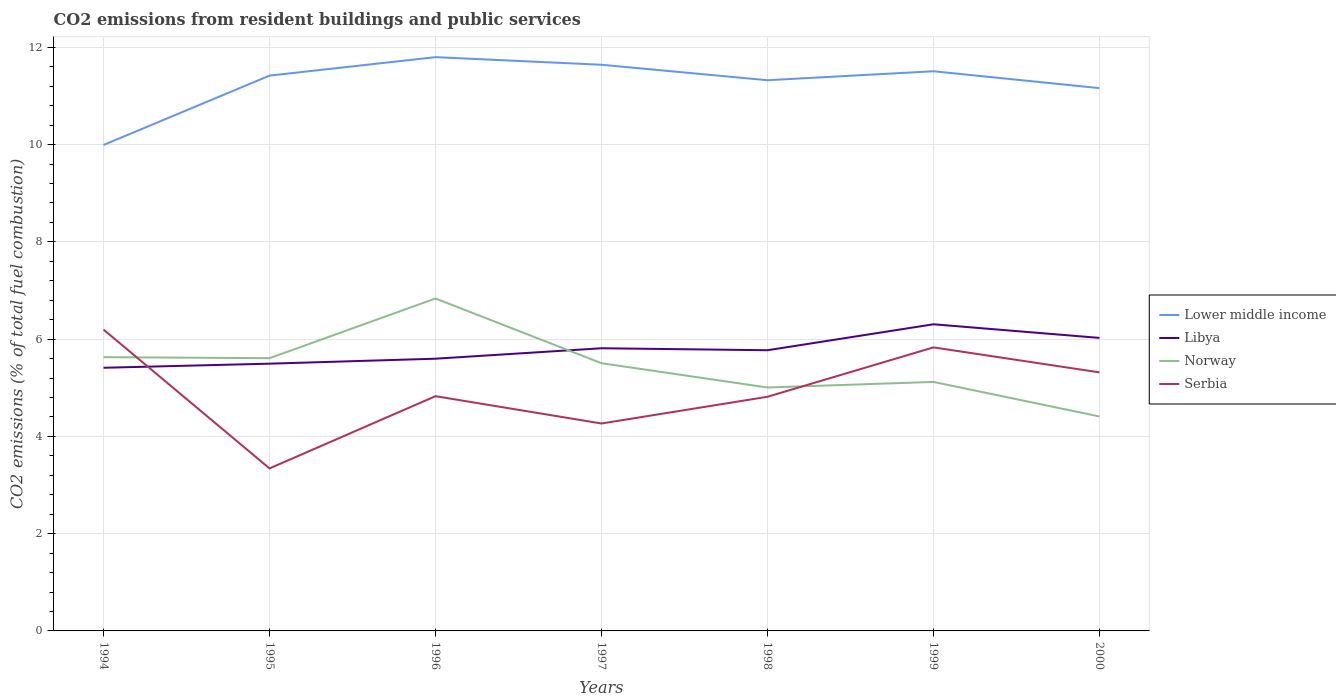How many different coloured lines are there?
Keep it short and to the point. 4. Does the line corresponding to Lower middle income intersect with the line corresponding to Norway?
Offer a very short reply. No. Across all years, what is the maximum total CO2 emitted in Norway?
Give a very brief answer. 4.41. What is the total total CO2 emitted in Norway in the graph?
Your answer should be very brief. 0.5. What is the difference between the highest and the second highest total CO2 emitted in Lower middle income?
Your response must be concise. 1.81. What is the difference between the highest and the lowest total CO2 emitted in Serbia?
Provide a short and direct response. 3. How many lines are there?
Your answer should be very brief. 4. How many years are there in the graph?
Offer a very short reply. 7. What is the difference between two consecutive major ticks on the Y-axis?
Ensure brevity in your answer.  2. Are the values on the major ticks of Y-axis written in scientific E-notation?
Provide a short and direct response. No. Does the graph contain grids?
Your answer should be compact. Yes. How are the legend labels stacked?
Your answer should be very brief. Vertical. What is the title of the graph?
Offer a very short reply. CO2 emissions from resident buildings and public services. What is the label or title of the X-axis?
Offer a very short reply. Years. What is the label or title of the Y-axis?
Make the answer very short. CO2 emissions (% of total fuel combustion). What is the CO2 emissions (% of total fuel combustion) of Lower middle income in 1994?
Provide a short and direct response. 9.99. What is the CO2 emissions (% of total fuel combustion) of Libya in 1994?
Offer a terse response. 5.41. What is the CO2 emissions (% of total fuel combustion) in Norway in 1994?
Give a very brief answer. 5.63. What is the CO2 emissions (% of total fuel combustion) in Serbia in 1994?
Keep it short and to the point. 6.2. What is the CO2 emissions (% of total fuel combustion) in Lower middle income in 1995?
Make the answer very short. 11.42. What is the CO2 emissions (% of total fuel combustion) of Libya in 1995?
Your answer should be very brief. 5.5. What is the CO2 emissions (% of total fuel combustion) of Norway in 1995?
Your response must be concise. 5.61. What is the CO2 emissions (% of total fuel combustion) of Serbia in 1995?
Your answer should be very brief. 3.34. What is the CO2 emissions (% of total fuel combustion) in Lower middle income in 1996?
Provide a short and direct response. 11.8. What is the CO2 emissions (% of total fuel combustion) of Libya in 1996?
Keep it short and to the point. 5.6. What is the CO2 emissions (% of total fuel combustion) in Norway in 1996?
Your answer should be very brief. 6.84. What is the CO2 emissions (% of total fuel combustion) of Serbia in 1996?
Offer a terse response. 4.83. What is the CO2 emissions (% of total fuel combustion) in Lower middle income in 1997?
Give a very brief answer. 11.64. What is the CO2 emissions (% of total fuel combustion) of Libya in 1997?
Offer a terse response. 5.81. What is the CO2 emissions (% of total fuel combustion) of Norway in 1997?
Your answer should be very brief. 5.51. What is the CO2 emissions (% of total fuel combustion) of Serbia in 1997?
Provide a short and direct response. 4.27. What is the CO2 emissions (% of total fuel combustion) of Lower middle income in 1998?
Offer a terse response. 11.32. What is the CO2 emissions (% of total fuel combustion) in Libya in 1998?
Your answer should be compact. 5.77. What is the CO2 emissions (% of total fuel combustion) of Norway in 1998?
Offer a very short reply. 5.01. What is the CO2 emissions (% of total fuel combustion) of Serbia in 1998?
Keep it short and to the point. 4.81. What is the CO2 emissions (% of total fuel combustion) of Lower middle income in 1999?
Make the answer very short. 11.51. What is the CO2 emissions (% of total fuel combustion) in Libya in 1999?
Ensure brevity in your answer.  6.31. What is the CO2 emissions (% of total fuel combustion) in Norway in 1999?
Give a very brief answer. 5.12. What is the CO2 emissions (% of total fuel combustion) of Serbia in 1999?
Make the answer very short. 5.83. What is the CO2 emissions (% of total fuel combustion) of Lower middle income in 2000?
Make the answer very short. 11.16. What is the CO2 emissions (% of total fuel combustion) in Libya in 2000?
Make the answer very short. 6.03. What is the CO2 emissions (% of total fuel combustion) of Norway in 2000?
Make the answer very short. 4.41. What is the CO2 emissions (% of total fuel combustion) of Serbia in 2000?
Provide a succinct answer. 5.32. Across all years, what is the maximum CO2 emissions (% of total fuel combustion) of Lower middle income?
Give a very brief answer. 11.8. Across all years, what is the maximum CO2 emissions (% of total fuel combustion) in Libya?
Provide a succinct answer. 6.31. Across all years, what is the maximum CO2 emissions (% of total fuel combustion) of Norway?
Your answer should be compact. 6.84. Across all years, what is the maximum CO2 emissions (% of total fuel combustion) of Serbia?
Keep it short and to the point. 6.2. Across all years, what is the minimum CO2 emissions (% of total fuel combustion) in Lower middle income?
Provide a succinct answer. 9.99. Across all years, what is the minimum CO2 emissions (% of total fuel combustion) of Libya?
Offer a very short reply. 5.41. Across all years, what is the minimum CO2 emissions (% of total fuel combustion) of Norway?
Provide a succinct answer. 4.41. Across all years, what is the minimum CO2 emissions (% of total fuel combustion) in Serbia?
Your answer should be compact. 3.34. What is the total CO2 emissions (% of total fuel combustion) of Lower middle income in the graph?
Ensure brevity in your answer.  78.84. What is the total CO2 emissions (% of total fuel combustion) in Libya in the graph?
Provide a succinct answer. 40.42. What is the total CO2 emissions (% of total fuel combustion) of Norway in the graph?
Your answer should be compact. 38.11. What is the total CO2 emissions (% of total fuel combustion) of Serbia in the graph?
Provide a succinct answer. 34.59. What is the difference between the CO2 emissions (% of total fuel combustion) of Lower middle income in 1994 and that in 1995?
Give a very brief answer. -1.43. What is the difference between the CO2 emissions (% of total fuel combustion) in Libya in 1994 and that in 1995?
Your answer should be compact. -0.08. What is the difference between the CO2 emissions (% of total fuel combustion) of Norway in 1994 and that in 1995?
Keep it short and to the point. 0.02. What is the difference between the CO2 emissions (% of total fuel combustion) of Serbia in 1994 and that in 1995?
Give a very brief answer. 2.85. What is the difference between the CO2 emissions (% of total fuel combustion) of Lower middle income in 1994 and that in 1996?
Your response must be concise. -1.81. What is the difference between the CO2 emissions (% of total fuel combustion) in Libya in 1994 and that in 1996?
Keep it short and to the point. -0.19. What is the difference between the CO2 emissions (% of total fuel combustion) of Norway in 1994 and that in 1996?
Your response must be concise. -1.21. What is the difference between the CO2 emissions (% of total fuel combustion) in Serbia in 1994 and that in 1996?
Keep it short and to the point. 1.37. What is the difference between the CO2 emissions (% of total fuel combustion) of Lower middle income in 1994 and that in 1997?
Your response must be concise. -1.65. What is the difference between the CO2 emissions (% of total fuel combustion) of Libya in 1994 and that in 1997?
Your answer should be very brief. -0.4. What is the difference between the CO2 emissions (% of total fuel combustion) in Norway in 1994 and that in 1997?
Offer a terse response. 0.12. What is the difference between the CO2 emissions (% of total fuel combustion) of Serbia in 1994 and that in 1997?
Your response must be concise. 1.93. What is the difference between the CO2 emissions (% of total fuel combustion) of Lower middle income in 1994 and that in 1998?
Your answer should be compact. -1.33. What is the difference between the CO2 emissions (% of total fuel combustion) in Libya in 1994 and that in 1998?
Provide a short and direct response. -0.36. What is the difference between the CO2 emissions (% of total fuel combustion) in Norway in 1994 and that in 1998?
Offer a terse response. 0.62. What is the difference between the CO2 emissions (% of total fuel combustion) in Serbia in 1994 and that in 1998?
Offer a terse response. 1.38. What is the difference between the CO2 emissions (% of total fuel combustion) in Lower middle income in 1994 and that in 1999?
Keep it short and to the point. -1.52. What is the difference between the CO2 emissions (% of total fuel combustion) in Libya in 1994 and that in 1999?
Keep it short and to the point. -0.89. What is the difference between the CO2 emissions (% of total fuel combustion) in Norway in 1994 and that in 1999?
Make the answer very short. 0.51. What is the difference between the CO2 emissions (% of total fuel combustion) of Serbia in 1994 and that in 1999?
Your answer should be compact. 0.37. What is the difference between the CO2 emissions (% of total fuel combustion) of Lower middle income in 1994 and that in 2000?
Your response must be concise. -1.17. What is the difference between the CO2 emissions (% of total fuel combustion) in Libya in 1994 and that in 2000?
Your response must be concise. -0.61. What is the difference between the CO2 emissions (% of total fuel combustion) in Norway in 1994 and that in 2000?
Your response must be concise. 1.22. What is the difference between the CO2 emissions (% of total fuel combustion) of Serbia in 1994 and that in 2000?
Make the answer very short. 0.88. What is the difference between the CO2 emissions (% of total fuel combustion) of Lower middle income in 1995 and that in 1996?
Your answer should be compact. -0.38. What is the difference between the CO2 emissions (% of total fuel combustion) in Libya in 1995 and that in 1996?
Offer a terse response. -0.1. What is the difference between the CO2 emissions (% of total fuel combustion) of Norway in 1995 and that in 1996?
Provide a short and direct response. -1.23. What is the difference between the CO2 emissions (% of total fuel combustion) in Serbia in 1995 and that in 1996?
Provide a succinct answer. -1.49. What is the difference between the CO2 emissions (% of total fuel combustion) in Lower middle income in 1995 and that in 1997?
Provide a succinct answer. -0.22. What is the difference between the CO2 emissions (% of total fuel combustion) of Libya in 1995 and that in 1997?
Your response must be concise. -0.32. What is the difference between the CO2 emissions (% of total fuel combustion) in Norway in 1995 and that in 1997?
Provide a succinct answer. 0.1. What is the difference between the CO2 emissions (% of total fuel combustion) in Serbia in 1995 and that in 1997?
Make the answer very short. -0.92. What is the difference between the CO2 emissions (% of total fuel combustion) in Lower middle income in 1995 and that in 1998?
Provide a short and direct response. 0.09. What is the difference between the CO2 emissions (% of total fuel combustion) of Libya in 1995 and that in 1998?
Give a very brief answer. -0.28. What is the difference between the CO2 emissions (% of total fuel combustion) of Norway in 1995 and that in 1998?
Keep it short and to the point. 0.6. What is the difference between the CO2 emissions (% of total fuel combustion) of Serbia in 1995 and that in 1998?
Your answer should be very brief. -1.47. What is the difference between the CO2 emissions (% of total fuel combustion) of Lower middle income in 1995 and that in 1999?
Make the answer very short. -0.09. What is the difference between the CO2 emissions (% of total fuel combustion) in Libya in 1995 and that in 1999?
Provide a succinct answer. -0.81. What is the difference between the CO2 emissions (% of total fuel combustion) of Norway in 1995 and that in 1999?
Your answer should be compact. 0.49. What is the difference between the CO2 emissions (% of total fuel combustion) in Serbia in 1995 and that in 1999?
Your answer should be very brief. -2.49. What is the difference between the CO2 emissions (% of total fuel combustion) in Lower middle income in 1995 and that in 2000?
Your answer should be very brief. 0.26. What is the difference between the CO2 emissions (% of total fuel combustion) of Libya in 1995 and that in 2000?
Your answer should be compact. -0.53. What is the difference between the CO2 emissions (% of total fuel combustion) of Norway in 1995 and that in 2000?
Your answer should be compact. 1.2. What is the difference between the CO2 emissions (% of total fuel combustion) of Serbia in 1995 and that in 2000?
Your answer should be compact. -1.97. What is the difference between the CO2 emissions (% of total fuel combustion) in Lower middle income in 1996 and that in 1997?
Provide a short and direct response. 0.16. What is the difference between the CO2 emissions (% of total fuel combustion) of Libya in 1996 and that in 1997?
Your answer should be compact. -0.21. What is the difference between the CO2 emissions (% of total fuel combustion) of Norway in 1996 and that in 1997?
Provide a succinct answer. 1.33. What is the difference between the CO2 emissions (% of total fuel combustion) of Serbia in 1996 and that in 1997?
Your answer should be very brief. 0.56. What is the difference between the CO2 emissions (% of total fuel combustion) in Lower middle income in 1996 and that in 1998?
Give a very brief answer. 0.47. What is the difference between the CO2 emissions (% of total fuel combustion) of Libya in 1996 and that in 1998?
Ensure brevity in your answer.  -0.17. What is the difference between the CO2 emissions (% of total fuel combustion) in Norway in 1996 and that in 1998?
Provide a short and direct response. 1.83. What is the difference between the CO2 emissions (% of total fuel combustion) in Serbia in 1996 and that in 1998?
Your response must be concise. 0.01. What is the difference between the CO2 emissions (% of total fuel combustion) in Lower middle income in 1996 and that in 1999?
Give a very brief answer. 0.29. What is the difference between the CO2 emissions (% of total fuel combustion) of Libya in 1996 and that in 1999?
Offer a very short reply. -0.71. What is the difference between the CO2 emissions (% of total fuel combustion) of Norway in 1996 and that in 1999?
Give a very brief answer. 1.72. What is the difference between the CO2 emissions (% of total fuel combustion) of Serbia in 1996 and that in 1999?
Make the answer very short. -1. What is the difference between the CO2 emissions (% of total fuel combustion) of Lower middle income in 1996 and that in 2000?
Ensure brevity in your answer.  0.64. What is the difference between the CO2 emissions (% of total fuel combustion) of Libya in 1996 and that in 2000?
Offer a very short reply. -0.43. What is the difference between the CO2 emissions (% of total fuel combustion) of Norway in 1996 and that in 2000?
Provide a short and direct response. 2.43. What is the difference between the CO2 emissions (% of total fuel combustion) in Serbia in 1996 and that in 2000?
Provide a succinct answer. -0.49. What is the difference between the CO2 emissions (% of total fuel combustion) of Lower middle income in 1997 and that in 1998?
Offer a very short reply. 0.32. What is the difference between the CO2 emissions (% of total fuel combustion) in Libya in 1997 and that in 1998?
Keep it short and to the point. 0.04. What is the difference between the CO2 emissions (% of total fuel combustion) of Norway in 1997 and that in 1998?
Provide a short and direct response. 0.5. What is the difference between the CO2 emissions (% of total fuel combustion) of Serbia in 1997 and that in 1998?
Your answer should be very brief. -0.55. What is the difference between the CO2 emissions (% of total fuel combustion) in Lower middle income in 1997 and that in 1999?
Keep it short and to the point. 0.13. What is the difference between the CO2 emissions (% of total fuel combustion) in Libya in 1997 and that in 1999?
Give a very brief answer. -0.49. What is the difference between the CO2 emissions (% of total fuel combustion) in Norway in 1997 and that in 1999?
Provide a succinct answer. 0.38. What is the difference between the CO2 emissions (% of total fuel combustion) of Serbia in 1997 and that in 1999?
Offer a terse response. -1.57. What is the difference between the CO2 emissions (% of total fuel combustion) in Lower middle income in 1997 and that in 2000?
Offer a very short reply. 0.48. What is the difference between the CO2 emissions (% of total fuel combustion) in Libya in 1997 and that in 2000?
Provide a succinct answer. -0.21. What is the difference between the CO2 emissions (% of total fuel combustion) of Norway in 1997 and that in 2000?
Provide a succinct answer. 1.1. What is the difference between the CO2 emissions (% of total fuel combustion) in Serbia in 1997 and that in 2000?
Keep it short and to the point. -1.05. What is the difference between the CO2 emissions (% of total fuel combustion) of Lower middle income in 1998 and that in 1999?
Your answer should be compact. -0.18. What is the difference between the CO2 emissions (% of total fuel combustion) of Libya in 1998 and that in 1999?
Provide a succinct answer. -0.53. What is the difference between the CO2 emissions (% of total fuel combustion) in Norway in 1998 and that in 1999?
Provide a short and direct response. -0.11. What is the difference between the CO2 emissions (% of total fuel combustion) in Serbia in 1998 and that in 1999?
Your answer should be compact. -1.02. What is the difference between the CO2 emissions (% of total fuel combustion) in Lower middle income in 1998 and that in 2000?
Your answer should be compact. 0.16. What is the difference between the CO2 emissions (% of total fuel combustion) of Libya in 1998 and that in 2000?
Your answer should be compact. -0.25. What is the difference between the CO2 emissions (% of total fuel combustion) of Norway in 1998 and that in 2000?
Offer a terse response. 0.6. What is the difference between the CO2 emissions (% of total fuel combustion) of Serbia in 1998 and that in 2000?
Offer a very short reply. -0.5. What is the difference between the CO2 emissions (% of total fuel combustion) in Lower middle income in 1999 and that in 2000?
Give a very brief answer. 0.35. What is the difference between the CO2 emissions (% of total fuel combustion) in Libya in 1999 and that in 2000?
Make the answer very short. 0.28. What is the difference between the CO2 emissions (% of total fuel combustion) of Norway in 1999 and that in 2000?
Keep it short and to the point. 0.71. What is the difference between the CO2 emissions (% of total fuel combustion) in Serbia in 1999 and that in 2000?
Your response must be concise. 0.51. What is the difference between the CO2 emissions (% of total fuel combustion) of Lower middle income in 1994 and the CO2 emissions (% of total fuel combustion) of Libya in 1995?
Give a very brief answer. 4.5. What is the difference between the CO2 emissions (% of total fuel combustion) in Lower middle income in 1994 and the CO2 emissions (% of total fuel combustion) in Norway in 1995?
Ensure brevity in your answer.  4.38. What is the difference between the CO2 emissions (% of total fuel combustion) of Lower middle income in 1994 and the CO2 emissions (% of total fuel combustion) of Serbia in 1995?
Offer a very short reply. 6.65. What is the difference between the CO2 emissions (% of total fuel combustion) of Libya in 1994 and the CO2 emissions (% of total fuel combustion) of Norway in 1995?
Make the answer very short. -0.2. What is the difference between the CO2 emissions (% of total fuel combustion) of Libya in 1994 and the CO2 emissions (% of total fuel combustion) of Serbia in 1995?
Ensure brevity in your answer.  2.07. What is the difference between the CO2 emissions (% of total fuel combustion) in Norway in 1994 and the CO2 emissions (% of total fuel combustion) in Serbia in 1995?
Offer a terse response. 2.29. What is the difference between the CO2 emissions (% of total fuel combustion) in Lower middle income in 1994 and the CO2 emissions (% of total fuel combustion) in Libya in 1996?
Make the answer very short. 4.39. What is the difference between the CO2 emissions (% of total fuel combustion) of Lower middle income in 1994 and the CO2 emissions (% of total fuel combustion) of Norway in 1996?
Give a very brief answer. 3.16. What is the difference between the CO2 emissions (% of total fuel combustion) in Lower middle income in 1994 and the CO2 emissions (% of total fuel combustion) in Serbia in 1996?
Your response must be concise. 5.17. What is the difference between the CO2 emissions (% of total fuel combustion) of Libya in 1994 and the CO2 emissions (% of total fuel combustion) of Norway in 1996?
Give a very brief answer. -1.42. What is the difference between the CO2 emissions (% of total fuel combustion) in Libya in 1994 and the CO2 emissions (% of total fuel combustion) in Serbia in 1996?
Provide a short and direct response. 0.58. What is the difference between the CO2 emissions (% of total fuel combustion) of Norway in 1994 and the CO2 emissions (% of total fuel combustion) of Serbia in 1996?
Keep it short and to the point. 0.8. What is the difference between the CO2 emissions (% of total fuel combustion) in Lower middle income in 1994 and the CO2 emissions (% of total fuel combustion) in Libya in 1997?
Offer a terse response. 4.18. What is the difference between the CO2 emissions (% of total fuel combustion) in Lower middle income in 1994 and the CO2 emissions (% of total fuel combustion) in Norway in 1997?
Provide a short and direct response. 4.49. What is the difference between the CO2 emissions (% of total fuel combustion) in Lower middle income in 1994 and the CO2 emissions (% of total fuel combustion) in Serbia in 1997?
Keep it short and to the point. 5.73. What is the difference between the CO2 emissions (% of total fuel combustion) of Libya in 1994 and the CO2 emissions (% of total fuel combustion) of Norway in 1997?
Ensure brevity in your answer.  -0.09. What is the difference between the CO2 emissions (% of total fuel combustion) in Libya in 1994 and the CO2 emissions (% of total fuel combustion) in Serbia in 1997?
Your answer should be compact. 1.15. What is the difference between the CO2 emissions (% of total fuel combustion) in Norway in 1994 and the CO2 emissions (% of total fuel combustion) in Serbia in 1997?
Provide a short and direct response. 1.36. What is the difference between the CO2 emissions (% of total fuel combustion) in Lower middle income in 1994 and the CO2 emissions (% of total fuel combustion) in Libya in 1998?
Provide a succinct answer. 4.22. What is the difference between the CO2 emissions (% of total fuel combustion) of Lower middle income in 1994 and the CO2 emissions (% of total fuel combustion) of Norway in 1998?
Provide a short and direct response. 4.99. What is the difference between the CO2 emissions (% of total fuel combustion) in Lower middle income in 1994 and the CO2 emissions (% of total fuel combustion) in Serbia in 1998?
Offer a very short reply. 5.18. What is the difference between the CO2 emissions (% of total fuel combustion) in Libya in 1994 and the CO2 emissions (% of total fuel combustion) in Norway in 1998?
Your answer should be compact. 0.41. What is the difference between the CO2 emissions (% of total fuel combustion) of Libya in 1994 and the CO2 emissions (% of total fuel combustion) of Serbia in 1998?
Keep it short and to the point. 0.6. What is the difference between the CO2 emissions (% of total fuel combustion) in Norway in 1994 and the CO2 emissions (% of total fuel combustion) in Serbia in 1998?
Your response must be concise. 0.81. What is the difference between the CO2 emissions (% of total fuel combustion) of Lower middle income in 1994 and the CO2 emissions (% of total fuel combustion) of Libya in 1999?
Ensure brevity in your answer.  3.69. What is the difference between the CO2 emissions (% of total fuel combustion) in Lower middle income in 1994 and the CO2 emissions (% of total fuel combustion) in Norway in 1999?
Provide a short and direct response. 4.87. What is the difference between the CO2 emissions (% of total fuel combustion) of Lower middle income in 1994 and the CO2 emissions (% of total fuel combustion) of Serbia in 1999?
Make the answer very short. 4.16. What is the difference between the CO2 emissions (% of total fuel combustion) in Libya in 1994 and the CO2 emissions (% of total fuel combustion) in Norway in 1999?
Give a very brief answer. 0.29. What is the difference between the CO2 emissions (% of total fuel combustion) in Libya in 1994 and the CO2 emissions (% of total fuel combustion) in Serbia in 1999?
Ensure brevity in your answer.  -0.42. What is the difference between the CO2 emissions (% of total fuel combustion) in Norway in 1994 and the CO2 emissions (% of total fuel combustion) in Serbia in 1999?
Your response must be concise. -0.2. What is the difference between the CO2 emissions (% of total fuel combustion) in Lower middle income in 1994 and the CO2 emissions (% of total fuel combustion) in Libya in 2000?
Keep it short and to the point. 3.97. What is the difference between the CO2 emissions (% of total fuel combustion) of Lower middle income in 1994 and the CO2 emissions (% of total fuel combustion) of Norway in 2000?
Your response must be concise. 5.58. What is the difference between the CO2 emissions (% of total fuel combustion) of Lower middle income in 1994 and the CO2 emissions (% of total fuel combustion) of Serbia in 2000?
Provide a succinct answer. 4.68. What is the difference between the CO2 emissions (% of total fuel combustion) in Libya in 1994 and the CO2 emissions (% of total fuel combustion) in Norway in 2000?
Your response must be concise. 1. What is the difference between the CO2 emissions (% of total fuel combustion) in Libya in 1994 and the CO2 emissions (% of total fuel combustion) in Serbia in 2000?
Offer a very short reply. 0.09. What is the difference between the CO2 emissions (% of total fuel combustion) in Norway in 1994 and the CO2 emissions (% of total fuel combustion) in Serbia in 2000?
Provide a short and direct response. 0.31. What is the difference between the CO2 emissions (% of total fuel combustion) in Lower middle income in 1995 and the CO2 emissions (% of total fuel combustion) in Libya in 1996?
Give a very brief answer. 5.82. What is the difference between the CO2 emissions (% of total fuel combustion) of Lower middle income in 1995 and the CO2 emissions (% of total fuel combustion) of Norway in 1996?
Offer a terse response. 4.58. What is the difference between the CO2 emissions (% of total fuel combustion) in Lower middle income in 1995 and the CO2 emissions (% of total fuel combustion) in Serbia in 1996?
Offer a very short reply. 6.59. What is the difference between the CO2 emissions (% of total fuel combustion) in Libya in 1995 and the CO2 emissions (% of total fuel combustion) in Norway in 1996?
Your answer should be very brief. -1.34. What is the difference between the CO2 emissions (% of total fuel combustion) in Libya in 1995 and the CO2 emissions (% of total fuel combustion) in Serbia in 1996?
Keep it short and to the point. 0.67. What is the difference between the CO2 emissions (% of total fuel combustion) in Norway in 1995 and the CO2 emissions (% of total fuel combustion) in Serbia in 1996?
Make the answer very short. 0.78. What is the difference between the CO2 emissions (% of total fuel combustion) of Lower middle income in 1995 and the CO2 emissions (% of total fuel combustion) of Libya in 1997?
Provide a short and direct response. 5.61. What is the difference between the CO2 emissions (% of total fuel combustion) of Lower middle income in 1995 and the CO2 emissions (% of total fuel combustion) of Norway in 1997?
Offer a terse response. 5.91. What is the difference between the CO2 emissions (% of total fuel combustion) of Lower middle income in 1995 and the CO2 emissions (% of total fuel combustion) of Serbia in 1997?
Your response must be concise. 7.15. What is the difference between the CO2 emissions (% of total fuel combustion) of Libya in 1995 and the CO2 emissions (% of total fuel combustion) of Norway in 1997?
Provide a short and direct response. -0.01. What is the difference between the CO2 emissions (% of total fuel combustion) in Libya in 1995 and the CO2 emissions (% of total fuel combustion) in Serbia in 1997?
Provide a succinct answer. 1.23. What is the difference between the CO2 emissions (% of total fuel combustion) of Norway in 1995 and the CO2 emissions (% of total fuel combustion) of Serbia in 1997?
Your answer should be compact. 1.34. What is the difference between the CO2 emissions (% of total fuel combustion) in Lower middle income in 1995 and the CO2 emissions (% of total fuel combustion) in Libya in 1998?
Your response must be concise. 5.65. What is the difference between the CO2 emissions (% of total fuel combustion) of Lower middle income in 1995 and the CO2 emissions (% of total fuel combustion) of Norway in 1998?
Your answer should be compact. 6.41. What is the difference between the CO2 emissions (% of total fuel combustion) in Lower middle income in 1995 and the CO2 emissions (% of total fuel combustion) in Serbia in 1998?
Offer a terse response. 6.6. What is the difference between the CO2 emissions (% of total fuel combustion) of Libya in 1995 and the CO2 emissions (% of total fuel combustion) of Norway in 1998?
Make the answer very short. 0.49. What is the difference between the CO2 emissions (% of total fuel combustion) in Libya in 1995 and the CO2 emissions (% of total fuel combustion) in Serbia in 1998?
Offer a very short reply. 0.68. What is the difference between the CO2 emissions (% of total fuel combustion) of Norway in 1995 and the CO2 emissions (% of total fuel combustion) of Serbia in 1998?
Ensure brevity in your answer.  0.79. What is the difference between the CO2 emissions (% of total fuel combustion) in Lower middle income in 1995 and the CO2 emissions (% of total fuel combustion) in Libya in 1999?
Ensure brevity in your answer.  5.11. What is the difference between the CO2 emissions (% of total fuel combustion) of Lower middle income in 1995 and the CO2 emissions (% of total fuel combustion) of Norway in 1999?
Your answer should be compact. 6.3. What is the difference between the CO2 emissions (% of total fuel combustion) of Lower middle income in 1995 and the CO2 emissions (% of total fuel combustion) of Serbia in 1999?
Your answer should be very brief. 5.59. What is the difference between the CO2 emissions (% of total fuel combustion) of Libya in 1995 and the CO2 emissions (% of total fuel combustion) of Norway in 1999?
Ensure brevity in your answer.  0.38. What is the difference between the CO2 emissions (% of total fuel combustion) in Libya in 1995 and the CO2 emissions (% of total fuel combustion) in Serbia in 1999?
Provide a short and direct response. -0.33. What is the difference between the CO2 emissions (% of total fuel combustion) in Norway in 1995 and the CO2 emissions (% of total fuel combustion) in Serbia in 1999?
Offer a terse response. -0.22. What is the difference between the CO2 emissions (% of total fuel combustion) in Lower middle income in 1995 and the CO2 emissions (% of total fuel combustion) in Libya in 2000?
Your answer should be compact. 5.39. What is the difference between the CO2 emissions (% of total fuel combustion) of Lower middle income in 1995 and the CO2 emissions (% of total fuel combustion) of Norway in 2000?
Offer a very short reply. 7.01. What is the difference between the CO2 emissions (% of total fuel combustion) in Lower middle income in 1995 and the CO2 emissions (% of total fuel combustion) in Serbia in 2000?
Offer a very short reply. 6.1. What is the difference between the CO2 emissions (% of total fuel combustion) of Libya in 1995 and the CO2 emissions (% of total fuel combustion) of Norway in 2000?
Make the answer very short. 1.09. What is the difference between the CO2 emissions (% of total fuel combustion) of Libya in 1995 and the CO2 emissions (% of total fuel combustion) of Serbia in 2000?
Provide a short and direct response. 0.18. What is the difference between the CO2 emissions (% of total fuel combustion) of Norway in 1995 and the CO2 emissions (% of total fuel combustion) of Serbia in 2000?
Provide a short and direct response. 0.29. What is the difference between the CO2 emissions (% of total fuel combustion) of Lower middle income in 1996 and the CO2 emissions (% of total fuel combustion) of Libya in 1997?
Give a very brief answer. 5.99. What is the difference between the CO2 emissions (% of total fuel combustion) of Lower middle income in 1996 and the CO2 emissions (% of total fuel combustion) of Norway in 1997?
Keep it short and to the point. 6.29. What is the difference between the CO2 emissions (% of total fuel combustion) of Lower middle income in 1996 and the CO2 emissions (% of total fuel combustion) of Serbia in 1997?
Your answer should be very brief. 7.53. What is the difference between the CO2 emissions (% of total fuel combustion) in Libya in 1996 and the CO2 emissions (% of total fuel combustion) in Norway in 1997?
Give a very brief answer. 0.09. What is the difference between the CO2 emissions (% of total fuel combustion) in Libya in 1996 and the CO2 emissions (% of total fuel combustion) in Serbia in 1997?
Ensure brevity in your answer.  1.33. What is the difference between the CO2 emissions (% of total fuel combustion) in Norway in 1996 and the CO2 emissions (% of total fuel combustion) in Serbia in 1997?
Offer a very short reply. 2.57. What is the difference between the CO2 emissions (% of total fuel combustion) in Lower middle income in 1996 and the CO2 emissions (% of total fuel combustion) in Libya in 1998?
Provide a succinct answer. 6.03. What is the difference between the CO2 emissions (% of total fuel combustion) in Lower middle income in 1996 and the CO2 emissions (% of total fuel combustion) in Norway in 1998?
Your answer should be compact. 6.79. What is the difference between the CO2 emissions (% of total fuel combustion) in Lower middle income in 1996 and the CO2 emissions (% of total fuel combustion) in Serbia in 1998?
Provide a short and direct response. 6.98. What is the difference between the CO2 emissions (% of total fuel combustion) of Libya in 1996 and the CO2 emissions (% of total fuel combustion) of Norway in 1998?
Ensure brevity in your answer.  0.59. What is the difference between the CO2 emissions (% of total fuel combustion) of Libya in 1996 and the CO2 emissions (% of total fuel combustion) of Serbia in 1998?
Your answer should be compact. 0.78. What is the difference between the CO2 emissions (% of total fuel combustion) in Norway in 1996 and the CO2 emissions (% of total fuel combustion) in Serbia in 1998?
Offer a very short reply. 2.02. What is the difference between the CO2 emissions (% of total fuel combustion) in Lower middle income in 1996 and the CO2 emissions (% of total fuel combustion) in Libya in 1999?
Your answer should be very brief. 5.49. What is the difference between the CO2 emissions (% of total fuel combustion) in Lower middle income in 1996 and the CO2 emissions (% of total fuel combustion) in Norway in 1999?
Your answer should be very brief. 6.68. What is the difference between the CO2 emissions (% of total fuel combustion) of Lower middle income in 1996 and the CO2 emissions (% of total fuel combustion) of Serbia in 1999?
Your answer should be compact. 5.97. What is the difference between the CO2 emissions (% of total fuel combustion) of Libya in 1996 and the CO2 emissions (% of total fuel combustion) of Norway in 1999?
Offer a terse response. 0.48. What is the difference between the CO2 emissions (% of total fuel combustion) of Libya in 1996 and the CO2 emissions (% of total fuel combustion) of Serbia in 1999?
Your answer should be compact. -0.23. What is the difference between the CO2 emissions (% of total fuel combustion) of Norway in 1996 and the CO2 emissions (% of total fuel combustion) of Serbia in 1999?
Keep it short and to the point. 1.01. What is the difference between the CO2 emissions (% of total fuel combustion) in Lower middle income in 1996 and the CO2 emissions (% of total fuel combustion) in Libya in 2000?
Your answer should be very brief. 5.77. What is the difference between the CO2 emissions (% of total fuel combustion) in Lower middle income in 1996 and the CO2 emissions (% of total fuel combustion) in Norway in 2000?
Ensure brevity in your answer.  7.39. What is the difference between the CO2 emissions (% of total fuel combustion) of Lower middle income in 1996 and the CO2 emissions (% of total fuel combustion) of Serbia in 2000?
Offer a very short reply. 6.48. What is the difference between the CO2 emissions (% of total fuel combustion) in Libya in 1996 and the CO2 emissions (% of total fuel combustion) in Norway in 2000?
Ensure brevity in your answer.  1.19. What is the difference between the CO2 emissions (% of total fuel combustion) in Libya in 1996 and the CO2 emissions (% of total fuel combustion) in Serbia in 2000?
Provide a succinct answer. 0.28. What is the difference between the CO2 emissions (% of total fuel combustion) of Norway in 1996 and the CO2 emissions (% of total fuel combustion) of Serbia in 2000?
Give a very brief answer. 1.52. What is the difference between the CO2 emissions (% of total fuel combustion) in Lower middle income in 1997 and the CO2 emissions (% of total fuel combustion) in Libya in 1998?
Your response must be concise. 5.87. What is the difference between the CO2 emissions (% of total fuel combustion) of Lower middle income in 1997 and the CO2 emissions (% of total fuel combustion) of Norway in 1998?
Provide a succinct answer. 6.64. What is the difference between the CO2 emissions (% of total fuel combustion) in Lower middle income in 1997 and the CO2 emissions (% of total fuel combustion) in Serbia in 1998?
Make the answer very short. 6.83. What is the difference between the CO2 emissions (% of total fuel combustion) in Libya in 1997 and the CO2 emissions (% of total fuel combustion) in Norway in 1998?
Offer a very short reply. 0.81. What is the difference between the CO2 emissions (% of total fuel combustion) in Libya in 1997 and the CO2 emissions (% of total fuel combustion) in Serbia in 1998?
Your response must be concise. 1. What is the difference between the CO2 emissions (% of total fuel combustion) of Norway in 1997 and the CO2 emissions (% of total fuel combustion) of Serbia in 1998?
Your response must be concise. 0.69. What is the difference between the CO2 emissions (% of total fuel combustion) of Lower middle income in 1997 and the CO2 emissions (% of total fuel combustion) of Libya in 1999?
Keep it short and to the point. 5.34. What is the difference between the CO2 emissions (% of total fuel combustion) in Lower middle income in 1997 and the CO2 emissions (% of total fuel combustion) in Norway in 1999?
Offer a terse response. 6.52. What is the difference between the CO2 emissions (% of total fuel combustion) of Lower middle income in 1997 and the CO2 emissions (% of total fuel combustion) of Serbia in 1999?
Your answer should be compact. 5.81. What is the difference between the CO2 emissions (% of total fuel combustion) of Libya in 1997 and the CO2 emissions (% of total fuel combustion) of Norway in 1999?
Make the answer very short. 0.69. What is the difference between the CO2 emissions (% of total fuel combustion) of Libya in 1997 and the CO2 emissions (% of total fuel combustion) of Serbia in 1999?
Give a very brief answer. -0.02. What is the difference between the CO2 emissions (% of total fuel combustion) of Norway in 1997 and the CO2 emissions (% of total fuel combustion) of Serbia in 1999?
Your answer should be very brief. -0.33. What is the difference between the CO2 emissions (% of total fuel combustion) of Lower middle income in 1997 and the CO2 emissions (% of total fuel combustion) of Libya in 2000?
Provide a short and direct response. 5.62. What is the difference between the CO2 emissions (% of total fuel combustion) of Lower middle income in 1997 and the CO2 emissions (% of total fuel combustion) of Norway in 2000?
Offer a very short reply. 7.23. What is the difference between the CO2 emissions (% of total fuel combustion) in Lower middle income in 1997 and the CO2 emissions (% of total fuel combustion) in Serbia in 2000?
Make the answer very short. 6.33. What is the difference between the CO2 emissions (% of total fuel combustion) of Libya in 1997 and the CO2 emissions (% of total fuel combustion) of Norway in 2000?
Give a very brief answer. 1.4. What is the difference between the CO2 emissions (% of total fuel combustion) in Libya in 1997 and the CO2 emissions (% of total fuel combustion) in Serbia in 2000?
Your answer should be very brief. 0.5. What is the difference between the CO2 emissions (% of total fuel combustion) of Norway in 1997 and the CO2 emissions (% of total fuel combustion) of Serbia in 2000?
Give a very brief answer. 0.19. What is the difference between the CO2 emissions (% of total fuel combustion) in Lower middle income in 1998 and the CO2 emissions (% of total fuel combustion) in Libya in 1999?
Keep it short and to the point. 5.02. What is the difference between the CO2 emissions (% of total fuel combustion) of Lower middle income in 1998 and the CO2 emissions (% of total fuel combustion) of Norway in 1999?
Make the answer very short. 6.2. What is the difference between the CO2 emissions (% of total fuel combustion) of Lower middle income in 1998 and the CO2 emissions (% of total fuel combustion) of Serbia in 1999?
Make the answer very short. 5.49. What is the difference between the CO2 emissions (% of total fuel combustion) in Libya in 1998 and the CO2 emissions (% of total fuel combustion) in Norway in 1999?
Keep it short and to the point. 0.65. What is the difference between the CO2 emissions (% of total fuel combustion) in Libya in 1998 and the CO2 emissions (% of total fuel combustion) in Serbia in 1999?
Give a very brief answer. -0.06. What is the difference between the CO2 emissions (% of total fuel combustion) in Norway in 1998 and the CO2 emissions (% of total fuel combustion) in Serbia in 1999?
Provide a short and direct response. -0.82. What is the difference between the CO2 emissions (% of total fuel combustion) in Lower middle income in 1998 and the CO2 emissions (% of total fuel combustion) in Libya in 2000?
Provide a short and direct response. 5.3. What is the difference between the CO2 emissions (% of total fuel combustion) of Lower middle income in 1998 and the CO2 emissions (% of total fuel combustion) of Norway in 2000?
Keep it short and to the point. 6.91. What is the difference between the CO2 emissions (% of total fuel combustion) of Lower middle income in 1998 and the CO2 emissions (% of total fuel combustion) of Serbia in 2000?
Your answer should be very brief. 6.01. What is the difference between the CO2 emissions (% of total fuel combustion) of Libya in 1998 and the CO2 emissions (% of total fuel combustion) of Norway in 2000?
Keep it short and to the point. 1.36. What is the difference between the CO2 emissions (% of total fuel combustion) in Libya in 1998 and the CO2 emissions (% of total fuel combustion) in Serbia in 2000?
Offer a very short reply. 0.46. What is the difference between the CO2 emissions (% of total fuel combustion) in Norway in 1998 and the CO2 emissions (% of total fuel combustion) in Serbia in 2000?
Keep it short and to the point. -0.31. What is the difference between the CO2 emissions (% of total fuel combustion) in Lower middle income in 1999 and the CO2 emissions (% of total fuel combustion) in Libya in 2000?
Your answer should be compact. 5.48. What is the difference between the CO2 emissions (% of total fuel combustion) in Lower middle income in 1999 and the CO2 emissions (% of total fuel combustion) in Norway in 2000?
Keep it short and to the point. 7.1. What is the difference between the CO2 emissions (% of total fuel combustion) of Lower middle income in 1999 and the CO2 emissions (% of total fuel combustion) of Serbia in 2000?
Your response must be concise. 6.19. What is the difference between the CO2 emissions (% of total fuel combustion) in Libya in 1999 and the CO2 emissions (% of total fuel combustion) in Norway in 2000?
Your answer should be very brief. 1.9. What is the difference between the CO2 emissions (% of total fuel combustion) of Libya in 1999 and the CO2 emissions (% of total fuel combustion) of Serbia in 2000?
Ensure brevity in your answer.  0.99. What is the difference between the CO2 emissions (% of total fuel combustion) of Norway in 1999 and the CO2 emissions (% of total fuel combustion) of Serbia in 2000?
Offer a terse response. -0.2. What is the average CO2 emissions (% of total fuel combustion) in Lower middle income per year?
Give a very brief answer. 11.26. What is the average CO2 emissions (% of total fuel combustion) of Libya per year?
Give a very brief answer. 5.77. What is the average CO2 emissions (% of total fuel combustion) of Norway per year?
Your response must be concise. 5.44. What is the average CO2 emissions (% of total fuel combustion) of Serbia per year?
Give a very brief answer. 4.94. In the year 1994, what is the difference between the CO2 emissions (% of total fuel combustion) of Lower middle income and CO2 emissions (% of total fuel combustion) of Libya?
Your answer should be compact. 4.58. In the year 1994, what is the difference between the CO2 emissions (% of total fuel combustion) in Lower middle income and CO2 emissions (% of total fuel combustion) in Norway?
Ensure brevity in your answer.  4.36. In the year 1994, what is the difference between the CO2 emissions (% of total fuel combustion) in Lower middle income and CO2 emissions (% of total fuel combustion) in Serbia?
Your response must be concise. 3.8. In the year 1994, what is the difference between the CO2 emissions (% of total fuel combustion) of Libya and CO2 emissions (% of total fuel combustion) of Norway?
Provide a succinct answer. -0.22. In the year 1994, what is the difference between the CO2 emissions (% of total fuel combustion) in Libya and CO2 emissions (% of total fuel combustion) in Serbia?
Ensure brevity in your answer.  -0.79. In the year 1994, what is the difference between the CO2 emissions (% of total fuel combustion) of Norway and CO2 emissions (% of total fuel combustion) of Serbia?
Your answer should be compact. -0.57. In the year 1995, what is the difference between the CO2 emissions (% of total fuel combustion) in Lower middle income and CO2 emissions (% of total fuel combustion) in Libya?
Offer a terse response. 5.92. In the year 1995, what is the difference between the CO2 emissions (% of total fuel combustion) in Lower middle income and CO2 emissions (% of total fuel combustion) in Norway?
Your answer should be compact. 5.81. In the year 1995, what is the difference between the CO2 emissions (% of total fuel combustion) of Lower middle income and CO2 emissions (% of total fuel combustion) of Serbia?
Offer a terse response. 8.08. In the year 1995, what is the difference between the CO2 emissions (% of total fuel combustion) in Libya and CO2 emissions (% of total fuel combustion) in Norway?
Ensure brevity in your answer.  -0.11. In the year 1995, what is the difference between the CO2 emissions (% of total fuel combustion) of Libya and CO2 emissions (% of total fuel combustion) of Serbia?
Your response must be concise. 2.15. In the year 1995, what is the difference between the CO2 emissions (% of total fuel combustion) in Norway and CO2 emissions (% of total fuel combustion) in Serbia?
Your answer should be compact. 2.27. In the year 1996, what is the difference between the CO2 emissions (% of total fuel combustion) in Lower middle income and CO2 emissions (% of total fuel combustion) in Libya?
Offer a very short reply. 6.2. In the year 1996, what is the difference between the CO2 emissions (% of total fuel combustion) in Lower middle income and CO2 emissions (% of total fuel combustion) in Norway?
Offer a terse response. 4.96. In the year 1996, what is the difference between the CO2 emissions (% of total fuel combustion) in Lower middle income and CO2 emissions (% of total fuel combustion) in Serbia?
Ensure brevity in your answer.  6.97. In the year 1996, what is the difference between the CO2 emissions (% of total fuel combustion) of Libya and CO2 emissions (% of total fuel combustion) of Norway?
Your answer should be compact. -1.24. In the year 1996, what is the difference between the CO2 emissions (% of total fuel combustion) of Libya and CO2 emissions (% of total fuel combustion) of Serbia?
Keep it short and to the point. 0.77. In the year 1996, what is the difference between the CO2 emissions (% of total fuel combustion) of Norway and CO2 emissions (% of total fuel combustion) of Serbia?
Your response must be concise. 2.01. In the year 1997, what is the difference between the CO2 emissions (% of total fuel combustion) of Lower middle income and CO2 emissions (% of total fuel combustion) of Libya?
Keep it short and to the point. 5.83. In the year 1997, what is the difference between the CO2 emissions (% of total fuel combustion) of Lower middle income and CO2 emissions (% of total fuel combustion) of Norway?
Your answer should be very brief. 6.14. In the year 1997, what is the difference between the CO2 emissions (% of total fuel combustion) in Lower middle income and CO2 emissions (% of total fuel combustion) in Serbia?
Provide a succinct answer. 7.38. In the year 1997, what is the difference between the CO2 emissions (% of total fuel combustion) of Libya and CO2 emissions (% of total fuel combustion) of Norway?
Your answer should be very brief. 0.31. In the year 1997, what is the difference between the CO2 emissions (% of total fuel combustion) of Libya and CO2 emissions (% of total fuel combustion) of Serbia?
Give a very brief answer. 1.55. In the year 1997, what is the difference between the CO2 emissions (% of total fuel combustion) in Norway and CO2 emissions (% of total fuel combustion) in Serbia?
Offer a terse response. 1.24. In the year 1998, what is the difference between the CO2 emissions (% of total fuel combustion) in Lower middle income and CO2 emissions (% of total fuel combustion) in Libya?
Provide a succinct answer. 5.55. In the year 1998, what is the difference between the CO2 emissions (% of total fuel combustion) in Lower middle income and CO2 emissions (% of total fuel combustion) in Norway?
Ensure brevity in your answer.  6.32. In the year 1998, what is the difference between the CO2 emissions (% of total fuel combustion) of Lower middle income and CO2 emissions (% of total fuel combustion) of Serbia?
Provide a short and direct response. 6.51. In the year 1998, what is the difference between the CO2 emissions (% of total fuel combustion) in Libya and CO2 emissions (% of total fuel combustion) in Norway?
Keep it short and to the point. 0.77. In the year 1998, what is the difference between the CO2 emissions (% of total fuel combustion) of Libya and CO2 emissions (% of total fuel combustion) of Serbia?
Your answer should be compact. 0.96. In the year 1998, what is the difference between the CO2 emissions (% of total fuel combustion) of Norway and CO2 emissions (% of total fuel combustion) of Serbia?
Your response must be concise. 0.19. In the year 1999, what is the difference between the CO2 emissions (% of total fuel combustion) in Lower middle income and CO2 emissions (% of total fuel combustion) in Libya?
Make the answer very short. 5.2. In the year 1999, what is the difference between the CO2 emissions (% of total fuel combustion) of Lower middle income and CO2 emissions (% of total fuel combustion) of Norway?
Make the answer very short. 6.39. In the year 1999, what is the difference between the CO2 emissions (% of total fuel combustion) of Lower middle income and CO2 emissions (% of total fuel combustion) of Serbia?
Offer a terse response. 5.68. In the year 1999, what is the difference between the CO2 emissions (% of total fuel combustion) of Libya and CO2 emissions (% of total fuel combustion) of Norway?
Your answer should be very brief. 1.19. In the year 1999, what is the difference between the CO2 emissions (% of total fuel combustion) of Libya and CO2 emissions (% of total fuel combustion) of Serbia?
Make the answer very short. 0.47. In the year 1999, what is the difference between the CO2 emissions (% of total fuel combustion) in Norway and CO2 emissions (% of total fuel combustion) in Serbia?
Your answer should be compact. -0.71. In the year 2000, what is the difference between the CO2 emissions (% of total fuel combustion) in Lower middle income and CO2 emissions (% of total fuel combustion) in Libya?
Your answer should be compact. 5.14. In the year 2000, what is the difference between the CO2 emissions (% of total fuel combustion) in Lower middle income and CO2 emissions (% of total fuel combustion) in Norway?
Offer a terse response. 6.75. In the year 2000, what is the difference between the CO2 emissions (% of total fuel combustion) of Lower middle income and CO2 emissions (% of total fuel combustion) of Serbia?
Offer a terse response. 5.84. In the year 2000, what is the difference between the CO2 emissions (% of total fuel combustion) of Libya and CO2 emissions (% of total fuel combustion) of Norway?
Provide a succinct answer. 1.62. In the year 2000, what is the difference between the CO2 emissions (% of total fuel combustion) of Libya and CO2 emissions (% of total fuel combustion) of Serbia?
Give a very brief answer. 0.71. In the year 2000, what is the difference between the CO2 emissions (% of total fuel combustion) in Norway and CO2 emissions (% of total fuel combustion) in Serbia?
Offer a very short reply. -0.91. What is the ratio of the CO2 emissions (% of total fuel combustion) of Lower middle income in 1994 to that in 1995?
Provide a succinct answer. 0.88. What is the ratio of the CO2 emissions (% of total fuel combustion) of Libya in 1994 to that in 1995?
Your answer should be very brief. 0.98. What is the ratio of the CO2 emissions (% of total fuel combustion) of Norway in 1994 to that in 1995?
Your answer should be compact. 1. What is the ratio of the CO2 emissions (% of total fuel combustion) in Serbia in 1994 to that in 1995?
Your answer should be very brief. 1.85. What is the ratio of the CO2 emissions (% of total fuel combustion) of Lower middle income in 1994 to that in 1996?
Keep it short and to the point. 0.85. What is the ratio of the CO2 emissions (% of total fuel combustion) of Libya in 1994 to that in 1996?
Your answer should be very brief. 0.97. What is the ratio of the CO2 emissions (% of total fuel combustion) of Norway in 1994 to that in 1996?
Your answer should be compact. 0.82. What is the ratio of the CO2 emissions (% of total fuel combustion) of Serbia in 1994 to that in 1996?
Ensure brevity in your answer.  1.28. What is the ratio of the CO2 emissions (% of total fuel combustion) in Lower middle income in 1994 to that in 1997?
Offer a terse response. 0.86. What is the ratio of the CO2 emissions (% of total fuel combustion) in Libya in 1994 to that in 1997?
Provide a short and direct response. 0.93. What is the ratio of the CO2 emissions (% of total fuel combustion) of Norway in 1994 to that in 1997?
Your response must be concise. 1.02. What is the ratio of the CO2 emissions (% of total fuel combustion) in Serbia in 1994 to that in 1997?
Make the answer very short. 1.45. What is the ratio of the CO2 emissions (% of total fuel combustion) of Lower middle income in 1994 to that in 1998?
Provide a succinct answer. 0.88. What is the ratio of the CO2 emissions (% of total fuel combustion) of Norway in 1994 to that in 1998?
Your response must be concise. 1.12. What is the ratio of the CO2 emissions (% of total fuel combustion) in Serbia in 1994 to that in 1998?
Offer a very short reply. 1.29. What is the ratio of the CO2 emissions (% of total fuel combustion) of Lower middle income in 1994 to that in 1999?
Ensure brevity in your answer.  0.87. What is the ratio of the CO2 emissions (% of total fuel combustion) of Libya in 1994 to that in 1999?
Offer a terse response. 0.86. What is the ratio of the CO2 emissions (% of total fuel combustion) in Norway in 1994 to that in 1999?
Your response must be concise. 1.1. What is the ratio of the CO2 emissions (% of total fuel combustion) of Serbia in 1994 to that in 1999?
Keep it short and to the point. 1.06. What is the ratio of the CO2 emissions (% of total fuel combustion) of Lower middle income in 1994 to that in 2000?
Ensure brevity in your answer.  0.9. What is the ratio of the CO2 emissions (% of total fuel combustion) of Libya in 1994 to that in 2000?
Offer a terse response. 0.9. What is the ratio of the CO2 emissions (% of total fuel combustion) in Norway in 1994 to that in 2000?
Ensure brevity in your answer.  1.28. What is the ratio of the CO2 emissions (% of total fuel combustion) of Serbia in 1994 to that in 2000?
Give a very brief answer. 1.17. What is the ratio of the CO2 emissions (% of total fuel combustion) of Lower middle income in 1995 to that in 1996?
Provide a short and direct response. 0.97. What is the ratio of the CO2 emissions (% of total fuel combustion) of Libya in 1995 to that in 1996?
Your answer should be compact. 0.98. What is the ratio of the CO2 emissions (% of total fuel combustion) in Norway in 1995 to that in 1996?
Keep it short and to the point. 0.82. What is the ratio of the CO2 emissions (% of total fuel combustion) in Serbia in 1995 to that in 1996?
Offer a terse response. 0.69. What is the ratio of the CO2 emissions (% of total fuel combustion) of Lower middle income in 1995 to that in 1997?
Provide a short and direct response. 0.98. What is the ratio of the CO2 emissions (% of total fuel combustion) in Libya in 1995 to that in 1997?
Keep it short and to the point. 0.95. What is the ratio of the CO2 emissions (% of total fuel combustion) of Norway in 1995 to that in 1997?
Make the answer very short. 1.02. What is the ratio of the CO2 emissions (% of total fuel combustion) in Serbia in 1995 to that in 1997?
Provide a short and direct response. 0.78. What is the ratio of the CO2 emissions (% of total fuel combustion) in Lower middle income in 1995 to that in 1998?
Your answer should be very brief. 1.01. What is the ratio of the CO2 emissions (% of total fuel combustion) in Libya in 1995 to that in 1998?
Give a very brief answer. 0.95. What is the ratio of the CO2 emissions (% of total fuel combustion) of Norway in 1995 to that in 1998?
Give a very brief answer. 1.12. What is the ratio of the CO2 emissions (% of total fuel combustion) in Serbia in 1995 to that in 1998?
Offer a terse response. 0.69. What is the ratio of the CO2 emissions (% of total fuel combustion) in Lower middle income in 1995 to that in 1999?
Provide a succinct answer. 0.99. What is the ratio of the CO2 emissions (% of total fuel combustion) of Libya in 1995 to that in 1999?
Provide a short and direct response. 0.87. What is the ratio of the CO2 emissions (% of total fuel combustion) of Norway in 1995 to that in 1999?
Keep it short and to the point. 1.1. What is the ratio of the CO2 emissions (% of total fuel combustion) of Serbia in 1995 to that in 1999?
Offer a terse response. 0.57. What is the ratio of the CO2 emissions (% of total fuel combustion) of Lower middle income in 1995 to that in 2000?
Offer a terse response. 1.02. What is the ratio of the CO2 emissions (% of total fuel combustion) of Libya in 1995 to that in 2000?
Keep it short and to the point. 0.91. What is the ratio of the CO2 emissions (% of total fuel combustion) in Norway in 1995 to that in 2000?
Your answer should be very brief. 1.27. What is the ratio of the CO2 emissions (% of total fuel combustion) of Serbia in 1995 to that in 2000?
Give a very brief answer. 0.63. What is the ratio of the CO2 emissions (% of total fuel combustion) in Lower middle income in 1996 to that in 1997?
Make the answer very short. 1.01. What is the ratio of the CO2 emissions (% of total fuel combustion) in Libya in 1996 to that in 1997?
Provide a short and direct response. 0.96. What is the ratio of the CO2 emissions (% of total fuel combustion) in Norway in 1996 to that in 1997?
Keep it short and to the point. 1.24. What is the ratio of the CO2 emissions (% of total fuel combustion) of Serbia in 1996 to that in 1997?
Provide a succinct answer. 1.13. What is the ratio of the CO2 emissions (% of total fuel combustion) of Lower middle income in 1996 to that in 1998?
Make the answer very short. 1.04. What is the ratio of the CO2 emissions (% of total fuel combustion) of Libya in 1996 to that in 1998?
Your answer should be very brief. 0.97. What is the ratio of the CO2 emissions (% of total fuel combustion) in Norway in 1996 to that in 1998?
Your answer should be compact. 1.37. What is the ratio of the CO2 emissions (% of total fuel combustion) of Serbia in 1996 to that in 1998?
Your answer should be very brief. 1. What is the ratio of the CO2 emissions (% of total fuel combustion) of Lower middle income in 1996 to that in 1999?
Provide a succinct answer. 1.03. What is the ratio of the CO2 emissions (% of total fuel combustion) of Libya in 1996 to that in 1999?
Offer a very short reply. 0.89. What is the ratio of the CO2 emissions (% of total fuel combustion) in Norway in 1996 to that in 1999?
Provide a short and direct response. 1.34. What is the ratio of the CO2 emissions (% of total fuel combustion) of Serbia in 1996 to that in 1999?
Provide a short and direct response. 0.83. What is the ratio of the CO2 emissions (% of total fuel combustion) of Lower middle income in 1996 to that in 2000?
Give a very brief answer. 1.06. What is the ratio of the CO2 emissions (% of total fuel combustion) of Libya in 1996 to that in 2000?
Offer a very short reply. 0.93. What is the ratio of the CO2 emissions (% of total fuel combustion) in Norway in 1996 to that in 2000?
Provide a succinct answer. 1.55. What is the ratio of the CO2 emissions (% of total fuel combustion) of Serbia in 1996 to that in 2000?
Keep it short and to the point. 0.91. What is the ratio of the CO2 emissions (% of total fuel combustion) of Lower middle income in 1997 to that in 1998?
Offer a very short reply. 1.03. What is the ratio of the CO2 emissions (% of total fuel combustion) of Libya in 1997 to that in 1998?
Your answer should be compact. 1.01. What is the ratio of the CO2 emissions (% of total fuel combustion) of Norway in 1997 to that in 1998?
Your answer should be compact. 1.1. What is the ratio of the CO2 emissions (% of total fuel combustion) in Serbia in 1997 to that in 1998?
Ensure brevity in your answer.  0.89. What is the ratio of the CO2 emissions (% of total fuel combustion) in Lower middle income in 1997 to that in 1999?
Provide a succinct answer. 1.01. What is the ratio of the CO2 emissions (% of total fuel combustion) in Libya in 1997 to that in 1999?
Provide a succinct answer. 0.92. What is the ratio of the CO2 emissions (% of total fuel combustion) in Norway in 1997 to that in 1999?
Make the answer very short. 1.08. What is the ratio of the CO2 emissions (% of total fuel combustion) in Serbia in 1997 to that in 1999?
Give a very brief answer. 0.73. What is the ratio of the CO2 emissions (% of total fuel combustion) of Lower middle income in 1997 to that in 2000?
Your response must be concise. 1.04. What is the ratio of the CO2 emissions (% of total fuel combustion) of Libya in 1997 to that in 2000?
Your answer should be compact. 0.96. What is the ratio of the CO2 emissions (% of total fuel combustion) in Norway in 1997 to that in 2000?
Ensure brevity in your answer.  1.25. What is the ratio of the CO2 emissions (% of total fuel combustion) of Serbia in 1997 to that in 2000?
Your answer should be compact. 0.8. What is the ratio of the CO2 emissions (% of total fuel combustion) in Libya in 1998 to that in 1999?
Keep it short and to the point. 0.92. What is the ratio of the CO2 emissions (% of total fuel combustion) in Norway in 1998 to that in 1999?
Give a very brief answer. 0.98. What is the ratio of the CO2 emissions (% of total fuel combustion) in Serbia in 1998 to that in 1999?
Your answer should be compact. 0.83. What is the ratio of the CO2 emissions (% of total fuel combustion) of Lower middle income in 1998 to that in 2000?
Make the answer very short. 1.01. What is the ratio of the CO2 emissions (% of total fuel combustion) of Libya in 1998 to that in 2000?
Ensure brevity in your answer.  0.96. What is the ratio of the CO2 emissions (% of total fuel combustion) of Norway in 1998 to that in 2000?
Your response must be concise. 1.14. What is the ratio of the CO2 emissions (% of total fuel combustion) of Serbia in 1998 to that in 2000?
Provide a succinct answer. 0.91. What is the ratio of the CO2 emissions (% of total fuel combustion) of Lower middle income in 1999 to that in 2000?
Give a very brief answer. 1.03. What is the ratio of the CO2 emissions (% of total fuel combustion) in Libya in 1999 to that in 2000?
Make the answer very short. 1.05. What is the ratio of the CO2 emissions (% of total fuel combustion) of Norway in 1999 to that in 2000?
Your answer should be very brief. 1.16. What is the ratio of the CO2 emissions (% of total fuel combustion) of Serbia in 1999 to that in 2000?
Provide a short and direct response. 1.1. What is the difference between the highest and the second highest CO2 emissions (% of total fuel combustion) in Lower middle income?
Make the answer very short. 0.16. What is the difference between the highest and the second highest CO2 emissions (% of total fuel combustion) in Libya?
Provide a short and direct response. 0.28. What is the difference between the highest and the second highest CO2 emissions (% of total fuel combustion) in Norway?
Make the answer very short. 1.21. What is the difference between the highest and the second highest CO2 emissions (% of total fuel combustion) in Serbia?
Keep it short and to the point. 0.37. What is the difference between the highest and the lowest CO2 emissions (% of total fuel combustion) of Lower middle income?
Ensure brevity in your answer.  1.81. What is the difference between the highest and the lowest CO2 emissions (% of total fuel combustion) in Libya?
Give a very brief answer. 0.89. What is the difference between the highest and the lowest CO2 emissions (% of total fuel combustion) of Norway?
Provide a short and direct response. 2.43. What is the difference between the highest and the lowest CO2 emissions (% of total fuel combustion) of Serbia?
Your answer should be very brief. 2.85. 